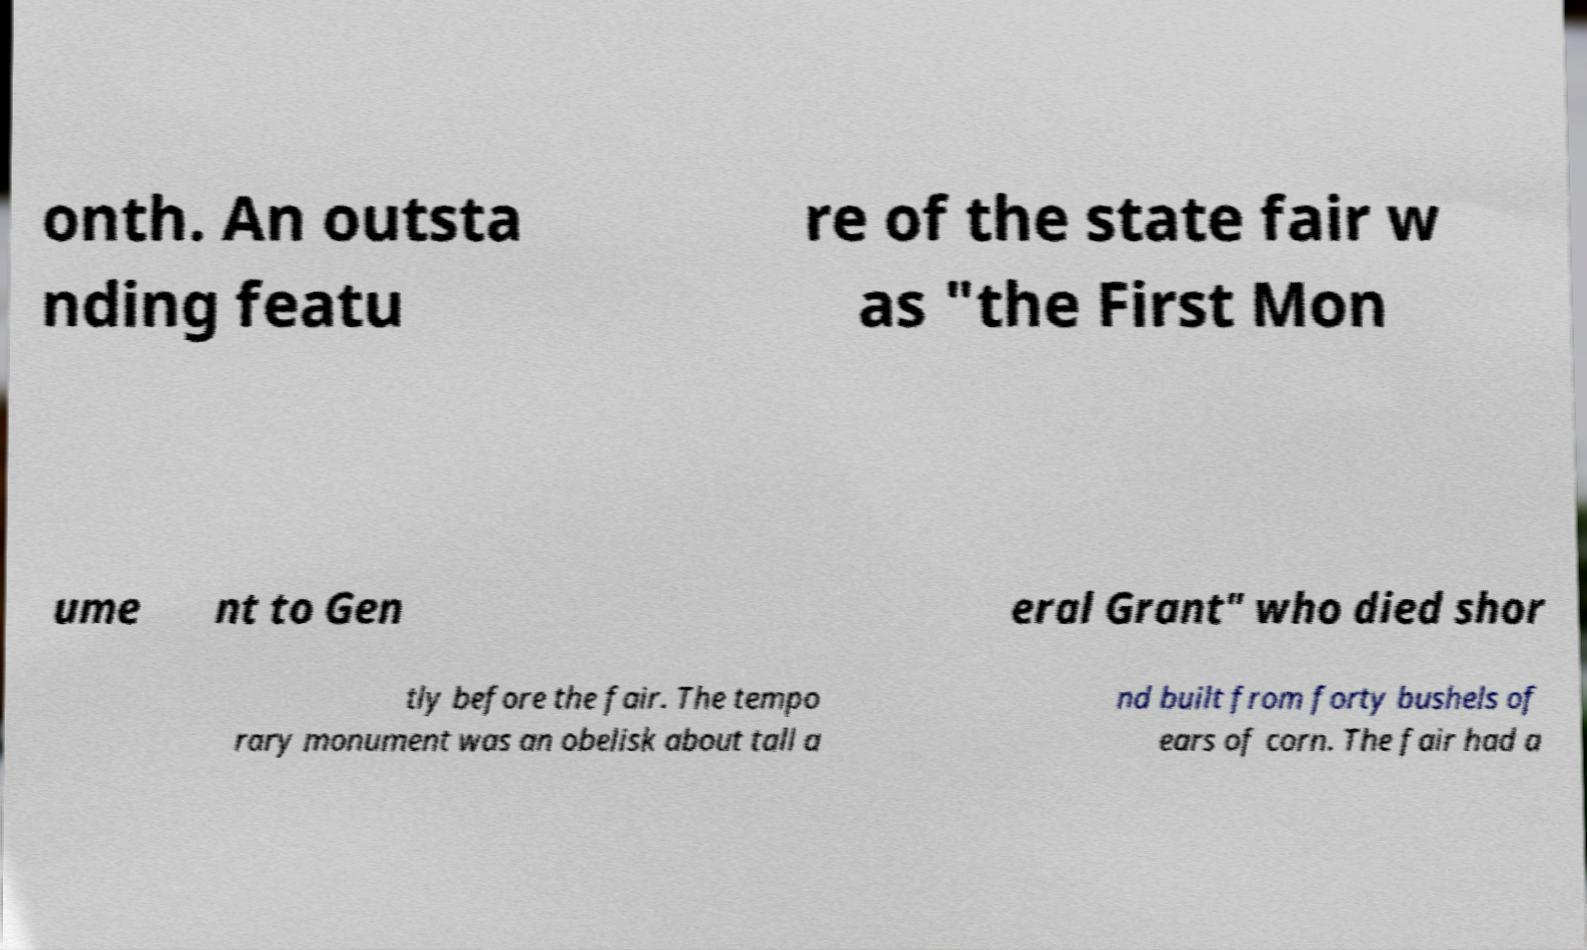Can you read and provide the text displayed in the image?This photo seems to have some interesting text. Can you extract and type it out for me? onth. An outsta nding featu re of the state fair w as "the First Mon ume nt to Gen eral Grant" who died shor tly before the fair. The tempo rary monument was an obelisk about tall a nd built from forty bushels of ears of corn. The fair had a 